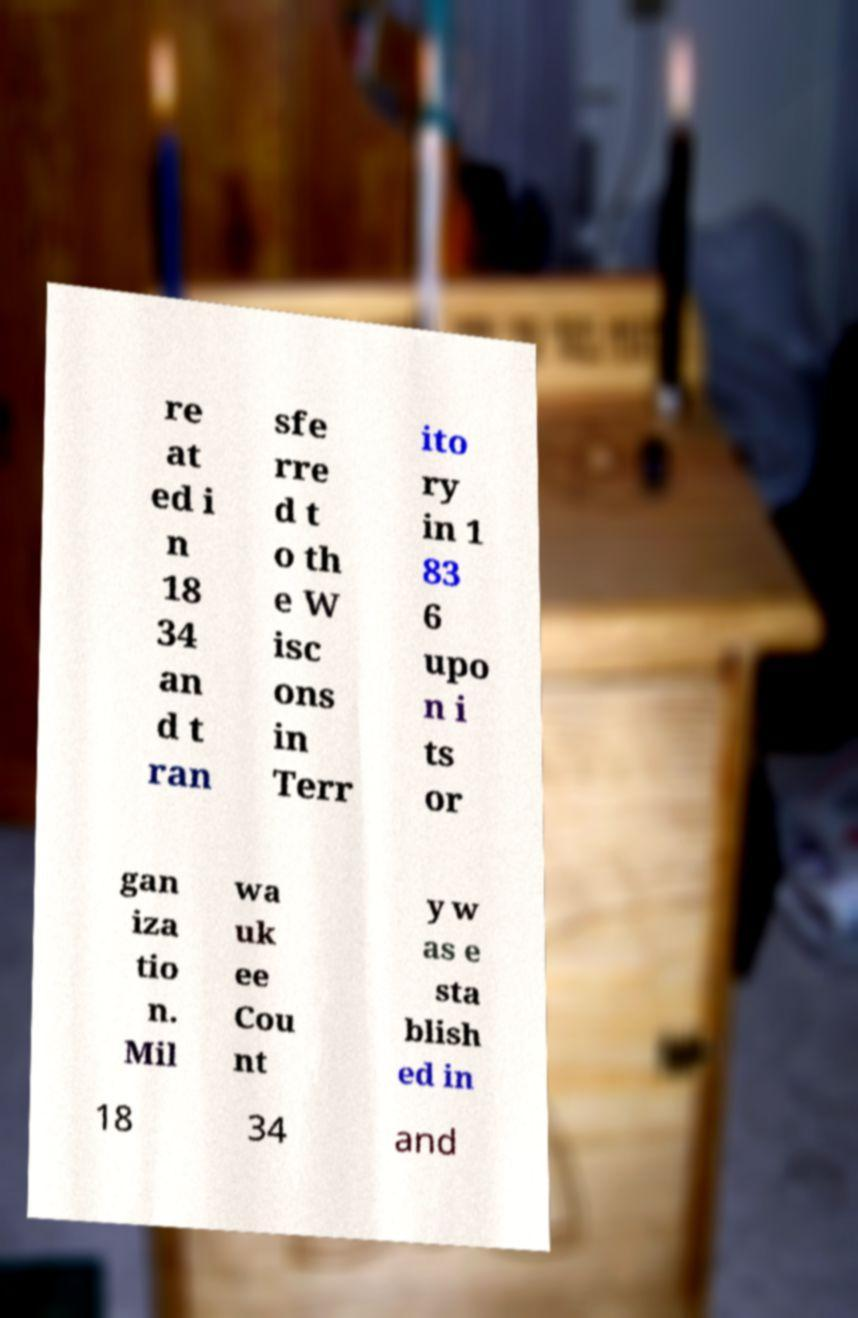Could you assist in decoding the text presented in this image and type it out clearly? re at ed i n 18 34 an d t ran sfe rre d t o th e W isc ons in Terr ito ry in 1 83 6 upo n i ts or gan iza tio n. Mil wa uk ee Cou nt y w as e sta blish ed in 18 34 and 